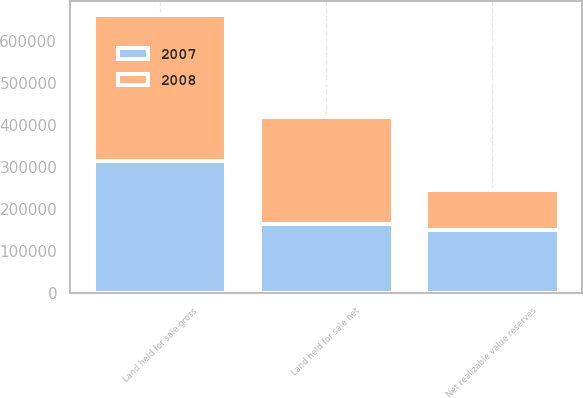Convert chart to OTSL. <chart><loc_0><loc_0><loc_500><loc_500><stacked_bar_chart><ecel><fcel>Land held for sale gross<fcel>Net realizable value reserves<fcel>Land held for sale net<nl><fcel>2007<fcel>314112<fcel>149158<fcel>164954<nl><fcel>2008<fcel>347758<fcel>95195<fcel>252563<nl></chart> 